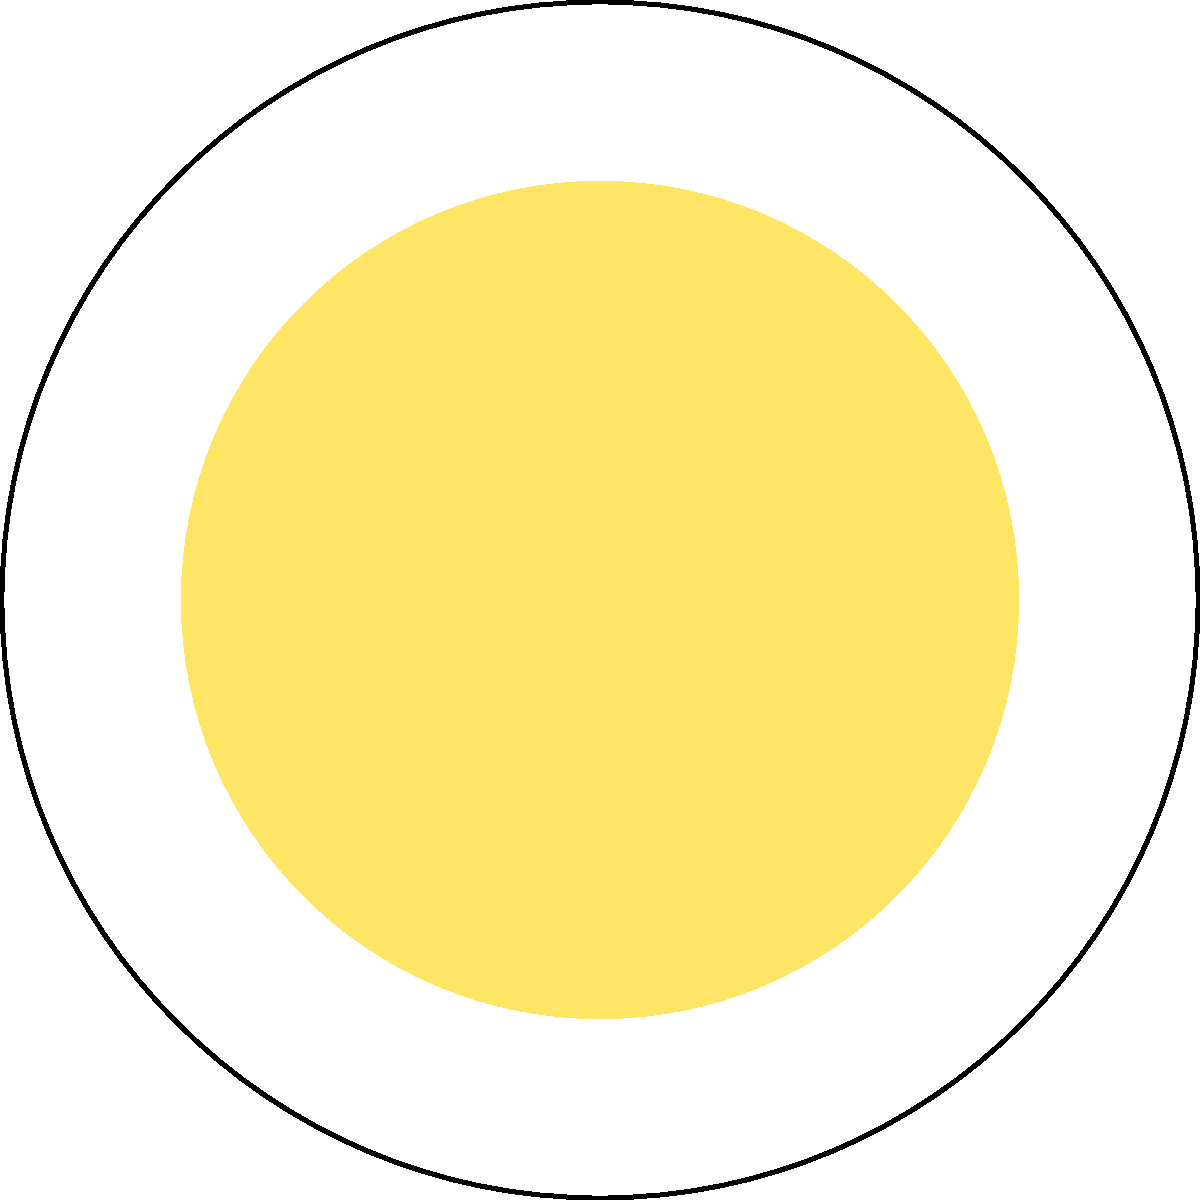In the cross-sectional diagram of the Sun, which layer is responsible for energy transfer primarily through the movement of plasma? Explain the physical process occurring in this layer and how it differs from the energy transfer mechanism in the layer beneath it. To answer this question, let's analyze the structure of the Sun from the inside out:

1. Core: This is the central region where nuclear fusion occurs, generating the Sun's energy.

2. Radiative Zone: In this layer, energy is transferred outward through radiation. Photons are continuously absorbed and re-emitted, slowly making their way outward.

3. Convection Zone: This is the layer we're looking for. In this zone, energy is transferred primarily through the movement of plasma.

4. Photosphere: This is the visible surface of the Sun.

The Convection Zone is responsible for energy transfer through the movement of plasma. The physical process occurring here is convection:

a) Hot plasma rises from the bottom of the convection zone.
b) As it reaches the surface, it cools and becomes denser.
c) The cooler, denser plasma then sinks back down.
d) This creates a circular motion, effectively transferring energy outward.

This process differs from the energy transfer mechanism in the Radiative Zone beneath it:

- In the Radiative Zone, energy is transferred through radiation (photons).
- The plasma in the Radiative Zone is too dense for convection to occur efficiently.
- The temperature gradient in the Convection Zone is steeper, making convection more efficient than radiation for energy transfer.

The transition between these two zones occurs at about 70% of the Sun's radius, where the temperature and density conditions change, making convection the dominant energy transfer mechanism.
Answer: Convection Zone 